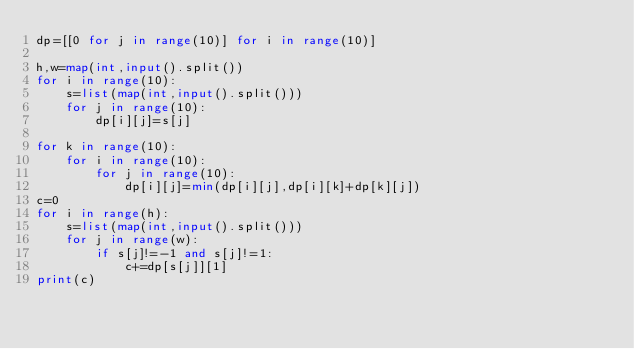Convert code to text. <code><loc_0><loc_0><loc_500><loc_500><_Python_>dp=[[0 for j in range(10)] for i in range(10)]

h,w=map(int,input().split())
for i in range(10):
    s=list(map(int,input().split()))
    for j in range(10):
        dp[i][j]=s[j]

for k in range(10):
    for i in range(10):
        for j in range(10):
            dp[i][j]=min(dp[i][j],dp[i][k]+dp[k][j])
c=0
for i in range(h):
    s=list(map(int,input().split()))
    for j in range(w):
        if s[j]!=-1 and s[j]!=1:
            c+=dp[s[j]][1]
print(c)
</code> 